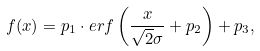<formula> <loc_0><loc_0><loc_500><loc_500>f ( x ) = p _ { 1 } \cdot e r f \left ( \frac { x } { \sqrt { 2 } \sigma } + p _ { 2 } \right ) + p _ { 3 } ,</formula> 